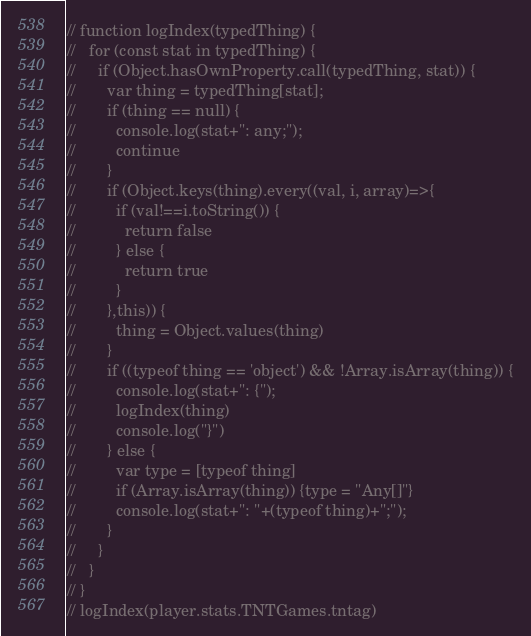Convert code to text. <code><loc_0><loc_0><loc_500><loc_500><_JavaScript_>// function logIndex(typedThing) {
//   for (const stat in typedThing) {
//     if (Object.hasOwnProperty.call(typedThing, stat)) {
//       var thing = typedThing[stat];
//       if (thing == null) {
//         console.log(stat+": any;");
//         continue
//       }
//       if (Object.keys(thing).every((val, i, array)=>{
//         if (val!==i.toString()) {
//           return false
//         } else {
//           return true
//         }
//       },this)) {
//         thing = Object.values(thing)
//       }
//       if ((typeof thing == 'object') && !Array.isArray(thing)) {
//         console.log(stat+": {");
//         logIndex(thing)
//         console.log("}")
//       } else {
//         var type = [typeof thing]
//         if (Array.isArray(thing)) {type = "Any[]"}
//         console.log(stat+": "+(typeof thing)+";");
//       }
//     }
//   }
// }
// logIndex(player.stats.TNTGames.tntag)</code> 